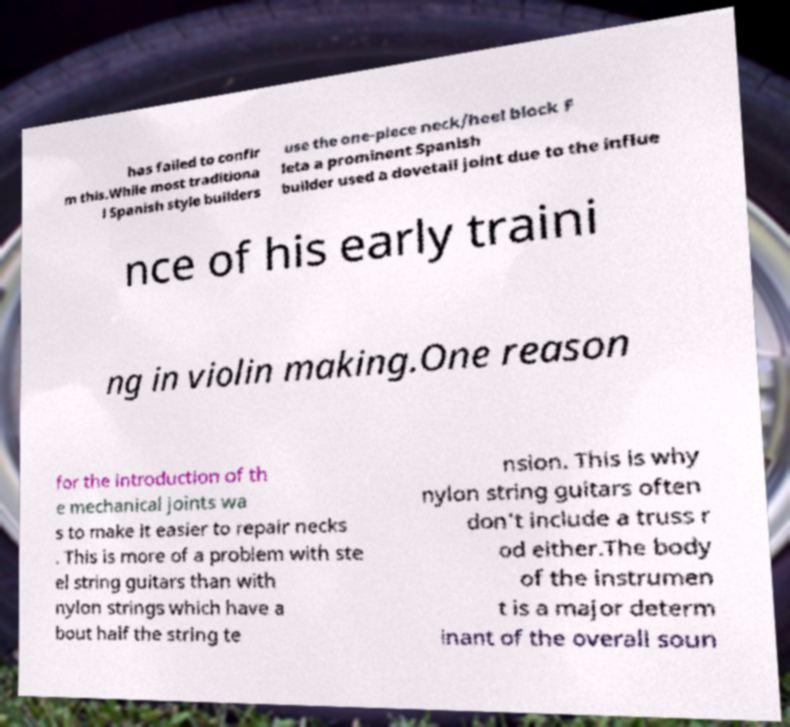Could you assist in decoding the text presented in this image and type it out clearly? has failed to confir m this.While most traditiona l Spanish style builders use the one-piece neck/heel block F leta a prominent Spanish builder used a dovetail joint due to the influe nce of his early traini ng in violin making.One reason for the introduction of th e mechanical joints wa s to make it easier to repair necks . This is more of a problem with ste el string guitars than with nylon strings which have a bout half the string te nsion. This is why nylon string guitars often don't include a truss r od either.The body of the instrumen t is a major determ inant of the overall soun 